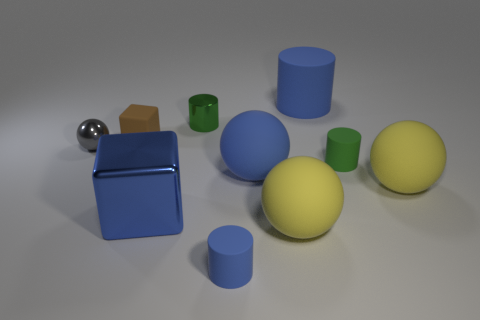Subtract all small balls. How many balls are left? 3 Subtract 3 cylinders. How many cylinders are left? 1 Subtract all blue cylinders. How many cylinders are left? 2 Subtract 0 cyan cylinders. How many objects are left? 10 Subtract all spheres. How many objects are left? 6 Subtract all gray cubes. Subtract all purple balls. How many cubes are left? 2 Subtract all gray balls. How many blue cylinders are left? 2 Subtract all blue shiny cubes. Subtract all large yellow rubber balls. How many objects are left? 7 Add 9 big blue cylinders. How many big blue cylinders are left? 10 Add 5 big blue metallic things. How many big blue metallic things exist? 6 